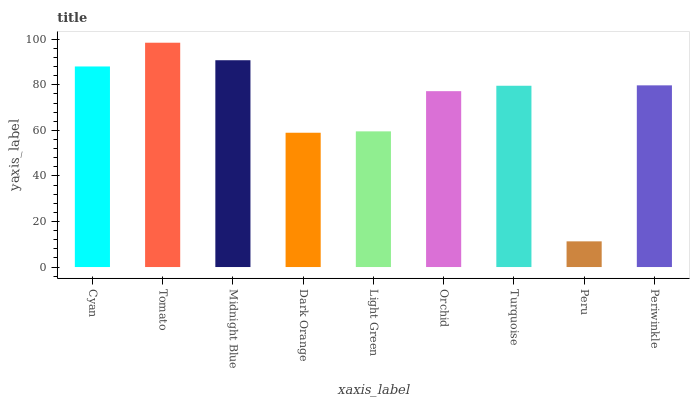Is Tomato the maximum?
Answer yes or no. Yes. Is Midnight Blue the minimum?
Answer yes or no. No. Is Midnight Blue the maximum?
Answer yes or no. No. Is Tomato greater than Midnight Blue?
Answer yes or no. Yes. Is Midnight Blue less than Tomato?
Answer yes or no. Yes. Is Midnight Blue greater than Tomato?
Answer yes or no. No. Is Tomato less than Midnight Blue?
Answer yes or no. No. Is Turquoise the high median?
Answer yes or no. Yes. Is Turquoise the low median?
Answer yes or no. Yes. Is Orchid the high median?
Answer yes or no. No. Is Peru the low median?
Answer yes or no. No. 